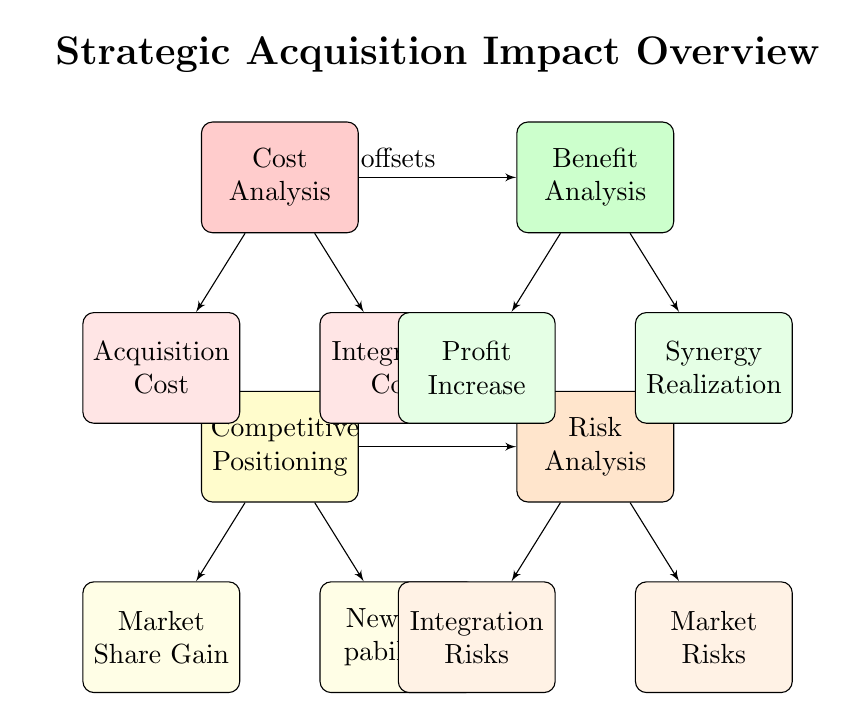What are the main components of the diagram? The main components are Cost Analysis, Benefit Analysis, Competitive Positioning, and Risk Analysis, as indicated by the main blocks in the diagram.
Answer: Cost Analysis, Benefit Analysis, Competitive Positioning, Risk Analysis How many subnodes are listed under Cost Analysis? There are two subnodes listed under Cost Analysis: Acquisition Cost and Integration Cost, as shown in the diagram.
Answer: 2 What is the relationship between Cost Analysis and Benefit Analysis? The diagram shows an arrow labeled "offsets" connecting Cost Analysis to Benefit Analysis, indicating that costs can offset benefits in the analysis.
Answer: offsets Which component contributes to Market Share Gain? Market Share Gain is a subnode of Competitive Positioning, indicating its contribution to competitive analysis.
Answer: Competitive Positioning What are the major risks identified in the Risk Analysis? The major risks identified are Integration Risks and Market Risks, as represented by the subnodes under Risk Analysis.
Answer: Integration Risks, Market Risks How do Profit Increase and Synergy Realization relate to Benefit Analysis? Both Profit Increase and Synergy Realization are directly connected as subnodes of Benefit Analysis, indicating they are key benefits considered in this analysis.
Answer: Directly connected Which two components are linked by Integration Costs? Integration Costs is linked to Cost Analysis as a subnode, showing that it is part of the cost consideration in the acquisition process.
Answer: Cost Analysis What is the primary goal of the Strategic Acquisition Impact Overview? The primary goal is to analyze the impact of strategic acquisitions through cost-benefit analysis, competitive positioning, and market share increase.
Answer: Analyze impact What color represents the Competitive Positioning block? The Competitive Positioning block is represented in yellow, as indicated in the diagram.
Answer: Yellow 